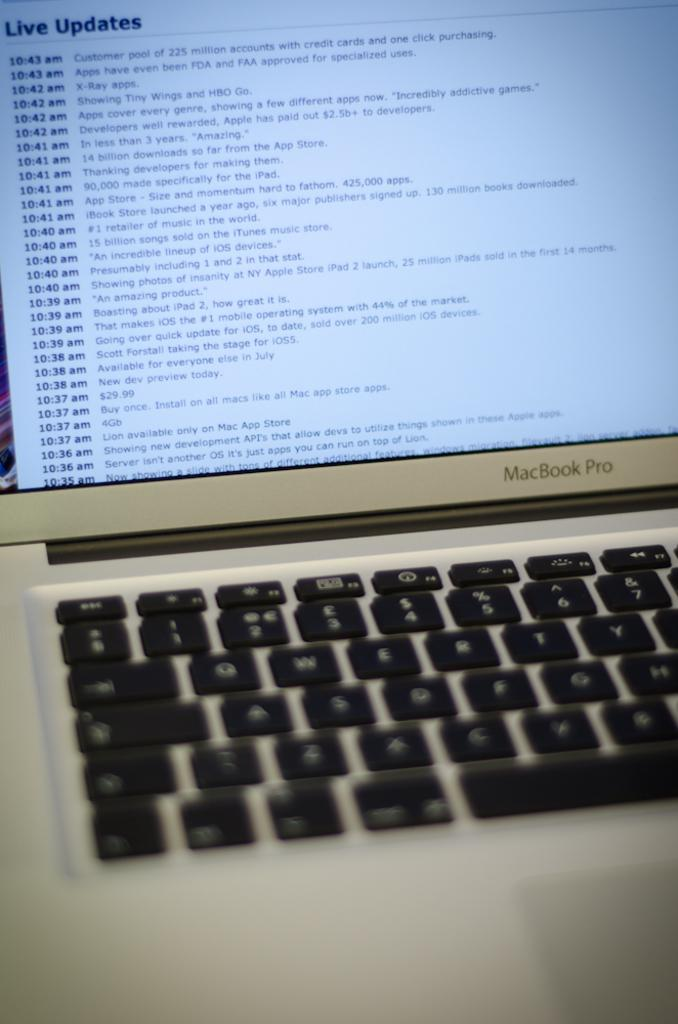What electronic device is present in the image? There is a laptop in the image. What is displayed on the laptop screen? There is text visible on the laptop screen. How many toys are scattered around the laptop in the image? There are no toys present in the image. What type of currency is shown on the laptop screen? The image does not show any money or currency on the laptop screen. 